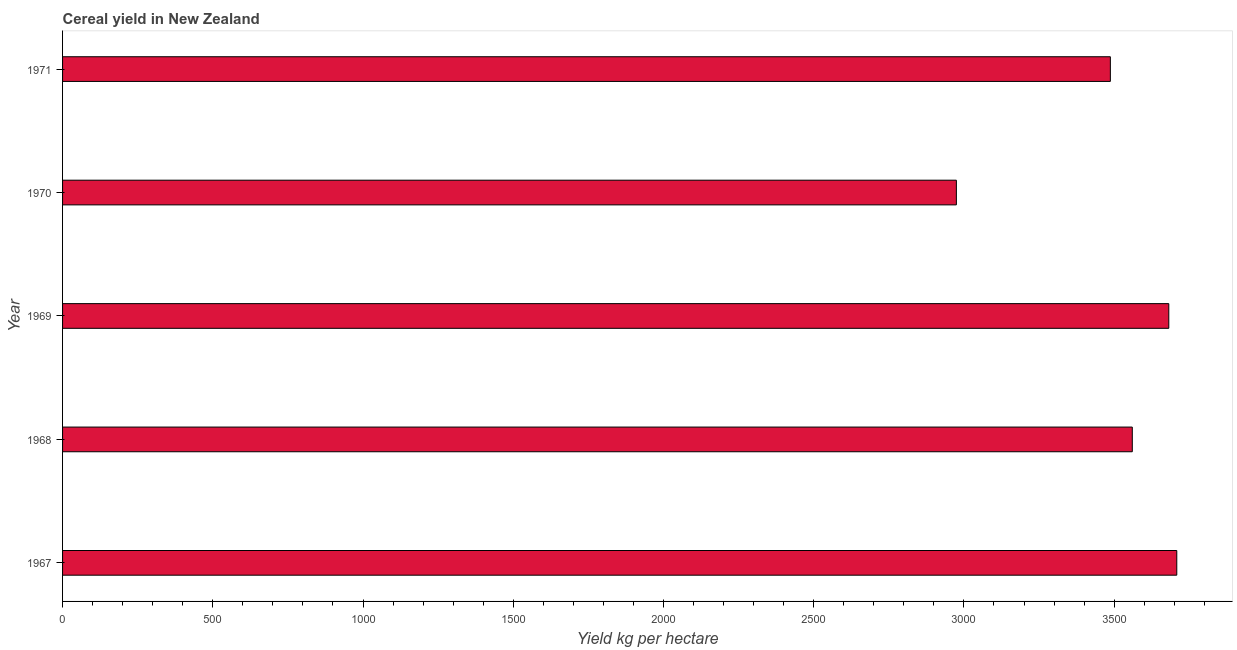Does the graph contain any zero values?
Make the answer very short. No. What is the title of the graph?
Give a very brief answer. Cereal yield in New Zealand. What is the label or title of the X-axis?
Your response must be concise. Yield kg per hectare. What is the label or title of the Y-axis?
Ensure brevity in your answer.  Year. What is the cereal yield in 1969?
Offer a very short reply. 3681.82. Across all years, what is the maximum cereal yield?
Keep it short and to the point. 3708.41. Across all years, what is the minimum cereal yield?
Provide a short and direct response. 2974.84. In which year was the cereal yield maximum?
Ensure brevity in your answer.  1967. In which year was the cereal yield minimum?
Your answer should be very brief. 1970. What is the sum of the cereal yield?
Your answer should be compact. 1.74e+04. What is the difference between the cereal yield in 1968 and 1970?
Your answer should be very brief. 585.53. What is the average cereal yield per year?
Provide a succinct answer. 3482.55. What is the median cereal yield?
Make the answer very short. 3560.36. What is the ratio of the cereal yield in 1967 to that in 1969?
Offer a terse response. 1.01. What is the difference between the highest and the second highest cereal yield?
Your answer should be very brief. 26.6. What is the difference between the highest and the lowest cereal yield?
Your answer should be compact. 733.58. In how many years, is the cereal yield greater than the average cereal yield taken over all years?
Give a very brief answer. 4. Are all the bars in the graph horizontal?
Provide a short and direct response. Yes. How many years are there in the graph?
Provide a succinct answer. 5. What is the difference between two consecutive major ticks on the X-axis?
Offer a very short reply. 500. Are the values on the major ticks of X-axis written in scientific E-notation?
Ensure brevity in your answer.  No. What is the Yield kg per hectare of 1967?
Keep it short and to the point. 3708.41. What is the Yield kg per hectare of 1968?
Your response must be concise. 3560.36. What is the Yield kg per hectare of 1969?
Your answer should be compact. 3681.82. What is the Yield kg per hectare in 1970?
Your response must be concise. 2974.84. What is the Yield kg per hectare in 1971?
Your answer should be very brief. 3487.34. What is the difference between the Yield kg per hectare in 1967 and 1968?
Your answer should be compact. 148.05. What is the difference between the Yield kg per hectare in 1967 and 1969?
Offer a terse response. 26.6. What is the difference between the Yield kg per hectare in 1967 and 1970?
Your answer should be compact. 733.58. What is the difference between the Yield kg per hectare in 1967 and 1971?
Make the answer very short. 221.07. What is the difference between the Yield kg per hectare in 1968 and 1969?
Give a very brief answer. -121.45. What is the difference between the Yield kg per hectare in 1968 and 1970?
Keep it short and to the point. 585.53. What is the difference between the Yield kg per hectare in 1968 and 1971?
Provide a succinct answer. 73.02. What is the difference between the Yield kg per hectare in 1969 and 1970?
Provide a succinct answer. 706.98. What is the difference between the Yield kg per hectare in 1969 and 1971?
Your answer should be compact. 194.47. What is the difference between the Yield kg per hectare in 1970 and 1971?
Give a very brief answer. -512.5. What is the ratio of the Yield kg per hectare in 1967 to that in 1968?
Provide a succinct answer. 1.04. What is the ratio of the Yield kg per hectare in 1967 to that in 1970?
Ensure brevity in your answer.  1.25. What is the ratio of the Yield kg per hectare in 1967 to that in 1971?
Ensure brevity in your answer.  1.06. What is the ratio of the Yield kg per hectare in 1968 to that in 1969?
Offer a terse response. 0.97. What is the ratio of the Yield kg per hectare in 1968 to that in 1970?
Offer a very short reply. 1.2. What is the ratio of the Yield kg per hectare in 1969 to that in 1970?
Give a very brief answer. 1.24. What is the ratio of the Yield kg per hectare in 1969 to that in 1971?
Provide a succinct answer. 1.06. What is the ratio of the Yield kg per hectare in 1970 to that in 1971?
Keep it short and to the point. 0.85. 